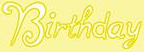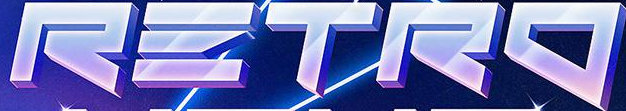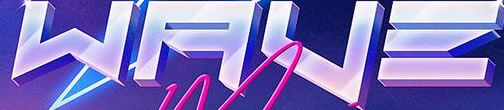What text is displayed in these images sequentially, separated by a semicolon? Birthday; RΞTRO; WAVΞ 